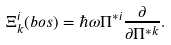<formula> <loc_0><loc_0><loc_500><loc_500>\Xi ^ { i } _ { k } ( b o s ) = \hbar { \omega } \Pi ^ { * i } \frac { \partial } { \partial \Pi ^ { * k } } .</formula> 